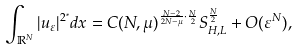<formula> <loc_0><loc_0><loc_500><loc_500>\int _ { \mathbb { R } ^ { N } } | u _ { \varepsilon } | ^ { 2 ^ { \ast } } d x = C ( N , \mu ) ^ { \frac { N - 2 } { 2 N - \mu } \cdot \frac { N } { 2 } } S _ { H , L } ^ { \frac { N } { 2 } } + O ( \varepsilon ^ { N } ) ,</formula> 